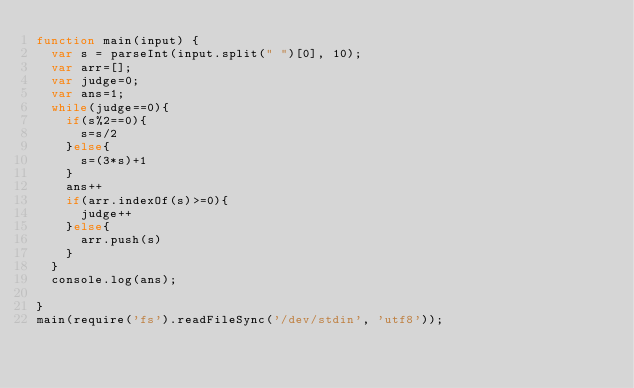Convert code to text. <code><loc_0><loc_0><loc_500><loc_500><_JavaScript_>function main(input) {
  var s = parseInt(input.split(" ")[0], 10);
  var arr=[];
  var judge=0;
  var ans=1;
  while(judge==0){
    if(s%2==0){
      s=s/2
    }else{
      s=(3*s)+1
    }
    ans++
    if(arr.indexOf(s)>=0){
      judge++
    }else{
      arr.push(s)
    }
  }
  console.log(ans);

}
main(require('fs').readFileSync('/dev/stdin', 'utf8'));</code> 